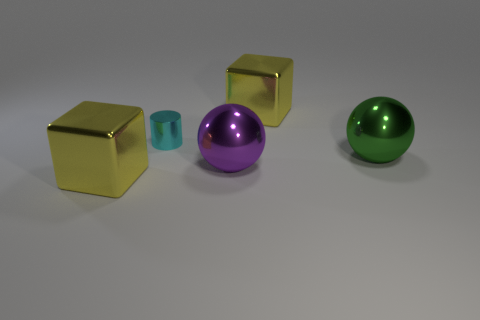Add 4 small cylinders. How many objects exist? 9 Subtract all cubes. How many objects are left? 3 Subtract 0 blue blocks. How many objects are left? 5 Subtract all large purple things. Subtract all tiny brown matte spheres. How many objects are left? 4 Add 2 cyan metallic cylinders. How many cyan metallic cylinders are left? 3 Add 2 cylinders. How many cylinders exist? 3 